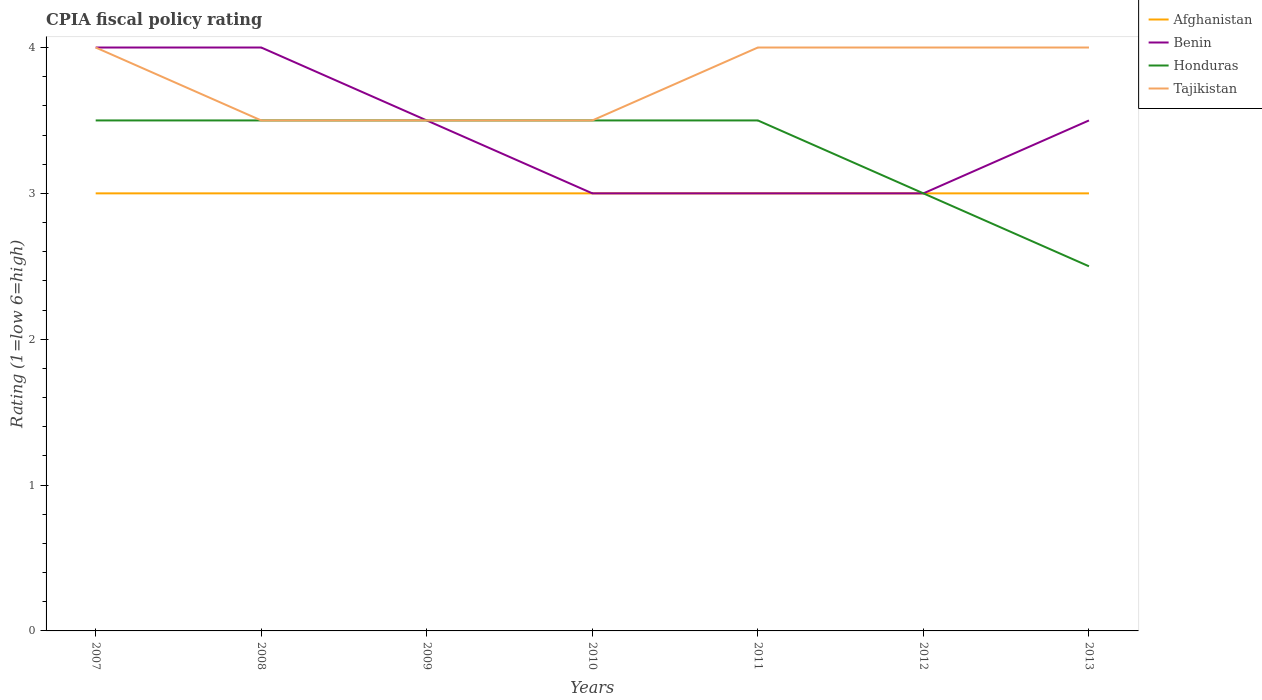How many different coloured lines are there?
Offer a very short reply. 4. Is the number of lines equal to the number of legend labels?
Keep it short and to the point. Yes. Across all years, what is the maximum CPIA rating in Honduras?
Provide a succinct answer. 2.5. In which year was the CPIA rating in Benin maximum?
Offer a terse response. 2010. What is the total CPIA rating in Benin in the graph?
Your answer should be compact. 0.5. What is the difference between the highest and the second highest CPIA rating in Benin?
Your response must be concise. 1. What is the difference between the highest and the lowest CPIA rating in Afghanistan?
Offer a very short reply. 0. Are the values on the major ticks of Y-axis written in scientific E-notation?
Make the answer very short. No. Does the graph contain any zero values?
Keep it short and to the point. No. Does the graph contain grids?
Your answer should be very brief. No. How are the legend labels stacked?
Your answer should be very brief. Vertical. What is the title of the graph?
Offer a terse response. CPIA fiscal policy rating. Does "Northern Mariana Islands" appear as one of the legend labels in the graph?
Make the answer very short. No. What is the Rating (1=low 6=high) in Benin in 2007?
Keep it short and to the point. 4. What is the Rating (1=low 6=high) of Honduras in 2008?
Keep it short and to the point. 3.5. What is the Rating (1=low 6=high) of Benin in 2009?
Your answer should be very brief. 3.5. What is the Rating (1=low 6=high) of Honduras in 2009?
Provide a short and direct response. 3.5. What is the Rating (1=low 6=high) in Benin in 2010?
Provide a succinct answer. 3. What is the Rating (1=low 6=high) in Honduras in 2010?
Keep it short and to the point. 3.5. What is the Rating (1=low 6=high) of Benin in 2011?
Provide a succinct answer. 3. What is the Rating (1=low 6=high) of Tajikistan in 2011?
Keep it short and to the point. 4. What is the Rating (1=low 6=high) of Afghanistan in 2012?
Make the answer very short. 3. What is the Rating (1=low 6=high) in Honduras in 2012?
Provide a succinct answer. 3. What is the Rating (1=low 6=high) of Tajikistan in 2012?
Offer a very short reply. 4. What is the Rating (1=low 6=high) of Afghanistan in 2013?
Ensure brevity in your answer.  3. Across all years, what is the maximum Rating (1=low 6=high) in Honduras?
Your response must be concise. 3.5. Across all years, what is the maximum Rating (1=low 6=high) in Tajikistan?
Keep it short and to the point. 4. Across all years, what is the minimum Rating (1=low 6=high) of Honduras?
Ensure brevity in your answer.  2.5. Across all years, what is the minimum Rating (1=low 6=high) of Tajikistan?
Ensure brevity in your answer.  3.5. What is the difference between the Rating (1=low 6=high) in Afghanistan in 2007 and that in 2008?
Keep it short and to the point. 0. What is the difference between the Rating (1=low 6=high) in Benin in 2007 and that in 2008?
Provide a succinct answer. 0. What is the difference between the Rating (1=low 6=high) of Honduras in 2007 and that in 2008?
Offer a very short reply. 0. What is the difference between the Rating (1=low 6=high) in Tajikistan in 2007 and that in 2008?
Provide a succinct answer. 0.5. What is the difference between the Rating (1=low 6=high) of Afghanistan in 2007 and that in 2009?
Offer a terse response. 0. What is the difference between the Rating (1=low 6=high) of Honduras in 2007 and that in 2009?
Give a very brief answer. 0. What is the difference between the Rating (1=low 6=high) in Tajikistan in 2007 and that in 2009?
Provide a succinct answer. 0.5. What is the difference between the Rating (1=low 6=high) in Honduras in 2007 and that in 2010?
Provide a short and direct response. 0. What is the difference between the Rating (1=low 6=high) in Benin in 2007 and that in 2011?
Provide a succinct answer. 1. What is the difference between the Rating (1=low 6=high) of Honduras in 2007 and that in 2011?
Keep it short and to the point. 0. What is the difference between the Rating (1=low 6=high) in Tajikistan in 2007 and that in 2011?
Your answer should be compact. 0. What is the difference between the Rating (1=low 6=high) of Afghanistan in 2007 and that in 2012?
Your answer should be very brief. 0. What is the difference between the Rating (1=low 6=high) in Benin in 2007 and that in 2012?
Your response must be concise. 1. What is the difference between the Rating (1=low 6=high) of Benin in 2007 and that in 2013?
Keep it short and to the point. 0.5. What is the difference between the Rating (1=low 6=high) in Afghanistan in 2008 and that in 2009?
Offer a very short reply. 0. What is the difference between the Rating (1=low 6=high) in Benin in 2008 and that in 2009?
Your answer should be compact. 0.5. What is the difference between the Rating (1=low 6=high) in Honduras in 2008 and that in 2010?
Keep it short and to the point. 0. What is the difference between the Rating (1=low 6=high) of Benin in 2008 and that in 2011?
Your answer should be very brief. 1. What is the difference between the Rating (1=low 6=high) of Honduras in 2008 and that in 2011?
Keep it short and to the point. 0. What is the difference between the Rating (1=low 6=high) of Afghanistan in 2008 and that in 2012?
Ensure brevity in your answer.  0. What is the difference between the Rating (1=low 6=high) of Honduras in 2008 and that in 2012?
Provide a short and direct response. 0.5. What is the difference between the Rating (1=low 6=high) in Tajikistan in 2008 and that in 2012?
Your response must be concise. -0.5. What is the difference between the Rating (1=low 6=high) in Afghanistan in 2008 and that in 2013?
Your answer should be compact. 0. What is the difference between the Rating (1=low 6=high) in Benin in 2009 and that in 2010?
Offer a terse response. 0.5. What is the difference between the Rating (1=low 6=high) of Honduras in 2009 and that in 2010?
Your answer should be very brief. 0. What is the difference between the Rating (1=low 6=high) of Afghanistan in 2009 and that in 2011?
Your answer should be very brief. 0. What is the difference between the Rating (1=low 6=high) in Tajikistan in 2009 and that in 2011?
Offer a very short reply. -0.5. What is the difference between the Rating (1=low 6=high) in Afghanistan in 2009 and that in 2012?
Ensure brevity in your answer.  0. What is the difference between the Rating (1=low 6=high) of Tajikistan in 2009 and that in 2012?
Offer a terse response. -0.5. What is the difference between the Rating (1=low 6=high) of Afghanistan in 2010 and that in 2011?
Make the answer very short. 0. What is the difference between the Rating (1=low 6=high) of Benin in 2010 and that in 2011?
Your answer should be compact. 0. What is the difference between the Rating (1=low 6=high) in Honduras in 2010 and that in 2011?
Make the answer very short. 0. What is the difference between the Rating (1=low 6=high) of Tajikistan in 2010 and that in 2011?
Give a very brief answer. -0.5. What is the difference between the Rating (1=low 6=high) of Afghanistan in 2010 and that in 2012?
Your response must be concise. 0. What is the difference between the Rating (1=low 6=high) in Benin in 2010 and that in 2012?
Your answer should be very brief. 0. What is the difference between the Rating (1=low 6=high) in Benin in 2010 and that in 2013?
Keep it short and to the point. -0.5. What is the difference between the Rating (1=low 6=high) of Tajikistan in 2010 and that in 2013?
Make the answer very short. -0.5. What is the difference between the Rating (1=low 6=high) of Afghanistan in 2011 and that in 2012?
Keep it short and to the point. 0. What is the difference between the Rating (1=low 6=high) in Benin in 2011 and that in 2012?
Your response must be concise. 0. What is the difference between the Rating (1=low 6=high) of Honduras in 2011 and that in 2012?
Your answer should be compact. 0.5. What is the difference between the Rating (1=low 6=high) of Tajikistan in 2011 and that in 2012?
Keep it short and to the point. 0. What is the difference between the Rating (1=low 6=high) of Honduras in 2011 and that in 2013?
Keep it short and to the point. 1. What is the difference between the Rating (1=low 6=high) of Honduras in 2012 and that in 2013?
Offer a terse response. 0.5. What is the difference between the Rating (1=low 6=high) of Tajikistan in 2012 and that in 2013?
Your response must be concise. 0. What is the difference between the Rating (1=low 6=high) of Afghanistan in 2007 and the Rating (1=low 6=high) of Benin in 2008?
Provide a short and direct response. -1. What is the difference between the Rating (1=low 6=high) of Afghanistan in 2007 and the Rating (1=low 6=high) of Honduras in 2008?
Offer a very short reply. -0.5. What is the difference between the Rating (1=low 6=high) of Benin in 2007 and the Rating (1=low 6=high) of Tajikistan in 2008?
Your answer should be very brief. 0.5. What is the difference between the Rating (1=low 6=high) of Honduras in 2007 and the Rating (1=low 6=high) of Tajikistan in 2008?
Make the answer very short. 0. What is the difference between the Rating (1=low 6=high) of Benin in 2007 and the Rating (1=low 6=high) of Honduras in 2009?
Ensure brevity in your answer.  0.5. What is the difference between the Rating (1=low 6=high) of Benin in 2007 and the Rating (1=low 6=high) of Tajikistan in 2009?
Make the answer very short. 0.5. What is the difference between the Rating (1=low 6=high) in Honduras in 2007 and the Rating (1=low 6=high) in Tajikistan in 2009?
Offer a very short reply. 0. What is the difference between the Rating (1=low 6=high) of Benin in 2007 and the Rating (1=low 6=high) of Honduras in 2010?
Your response must be concise. 0.5. What is the difference between the Rating (1=low 6=high) of Afghanistan in 2007 and the Rating (1=low 6=high) of Honduras in 2011?
Offer a very short reply. -0.5. What is the difference between the Rating (1=low 6=high) in Benin in 2007 and the Rating (1=low 6=high) in Tajikistan in 2011?
Keep it short and to the point. 0. What is the difference between the Rating (1=low 6=high) in Benin in 2007 and the Rating (1=low 6=high) in Tajikistan in 2012?
Your response must be concise. 0. What is the difference between the Rating (1=low 6=high) of Honduras in 2007 and the Rating (1=low 6=high) of Tajikistan in 2012?
Make the answer very short. -0.5. What is the difference between the Rating (1=low 6=high) of Afghanistan in 2007 and the Rating (1=low 6=high) of Honduras in 2013?
Make the answer very short. 0.5. What is the difference between the Rating (1=low 6=high) in Benin in 2007 and the Rating (1=low 6=high) in Tajikistan in 2013?
Keep it short and to the point. 0. What is the difference between the Rating (1=low 6=high) in Honduras in 2007 and the Rating (1=low 6=high) in Tajikistan in 2013?
Offer a terse response. -0.5. What is the difference between the Rating (1=low 6=high) of Afghanistan in 2008 and the Rating (1=low 6=high) of Benin in 2009?
Offer a very short reply. -0.5. What is the difference between the Rating (1=low 6=high) of Afghanistan in 2008 and the Rating (1=low 6=high) of Honduras in 2009?
Offer a terse response. -0.5. What is the difference between the Rating (1=low 6=high) in Benin in 2008 and the Rating (1=low 6=high) in Honduras in 2009?
Your answer should be compact. 0.5. What is the difference between the Rating (1=low 6=high) in Afghanistan in 2008 and the Rating (1=low 6=high) in Benin in 2010?
Your answer should be compact. 0. What is the difference between the Rating (1=low 6=high) of Afghanistan in 2008 and the Rating (1=low 6=high) of Honduras in 2010?
Your response must be concise. -0.5. What is the difference between the Rating (1=low 6=high) of Afghanistan in 2008 and the Rating (1=low 6=high) of Tajikistan in 2010?
Give a very brief answer. -0.5. What is the difference between the Rating (1=low 6=high) of Benin in 2008 and the Rating (1=low 6=high) of Tajikistan in 2010?
Your answer should be compact. 0.5. What is the difference between the Rating (1=low 6=high) in Afghanistan in 2008 and the Rating (1=low 6=high) in Benin in 2011?
Ensure brevity in your answer.  0. What is the difference between the Rating (1=low 6=high) of Honduras in 2008 and the Rating (1=low 6=high) of Tajikistan in 2011?
Make the answer very short. -0.5. What is the difference between the Rating (1=low 6=high) of Benin in 2008 and the Rating (1=low 6=high) of Tajikistan in 2012?
Ensure brevity in your answer.  0. What is the difference between the Rating (1=low 6=high) of Afghanistan in 2008 and the Rating (1=low 6=high) of Benin in 2013?
Your response must be concise. -0.5. What is the difference between the Rating (1=low 6=high) in Benin in 2008 and the Rating (1=low 6=high) in Tajikistan in 2013?
Ensure brevity in your answer.  0. What is the difference between the Rating (1=low 6=high) of Benin in 2009 and the Rating (1=low 6=high) of Honduras in 2010?
Keep it short and to the point. 0. What is the difference between the Rating (1=low 6=high) of Honduras in 2009 and the Rating (1=low 6=high) of Tajikistan in 2010?
Your answer should be compact. 0. What is the difference between the Rating (1=low 6=high) in Afghanistan in 2009 and the Rating (1=low 6=high) in Tajikistan in 2011?
Provide a short and direct response. -1. What is the difference between the Rating (1=low 6=high) of Benin in 2009 and the Rating (1=low 6=high) of Honduras in 2011?
Your answer should be very brief. 0. What is the difference between the Rating (1=low 6=high) in Afghanistan in 2009 and the Rating (1=low 6=high) in Benin in 2012?
Give a very brief answer. 0. What is the difference between the Rating (1=low 6=high) of Benin in 2009 and the Rating (1=low 6=high) of Honduras in 2012?
Your answer should be very brief. 0.5. What is the difference between the Rating (1=low 6=high) in Afghanistan in 2009 and the Rating (1=low 6=high) in Honduras in 2013?
Offer a very short reply. 0.5. What is the difference between the Rating (1=low 6=high) in Benin in 2009 and the Rating (1=low 6=high) in Honduras in 2013?
Offer a terse response. 1. What is the difference between the Rating (1=low 6=high) of Honduras in 2009 and the Rating (1=low 6=high) of Tajikistan in 2013?
Offer a terse response. -0.5. What is the difference between the Rating (1=low 6=high) in Afghanistan in 2010 and the Rating (1=low 6=high) in Benin in 2011?
Provide a short and direct response. 0. What is the difference between the Rating (1=low 6=high) of Benin in 2010 and the Rating (1=low 6=high) of Honduras in 2011?
Ensure brevity in your answer.  -0.5. What is the difference between the Rating (1=low 6=high) of Benin in 2010 and the Rating (1=low 6=high) of Tajikistan in 2011?
Provide a succinct answer. -1. What is the difference between the Rating (1=low 6=high) of Afghanistan in 2010 and the Rating (1=low 6=high) of Benin in 2012?
Your response must be concise. 0. What is the difference between the Rating (1=low 6=high) in Benin in 2010 and the Rating (1=low 6=high) in Tajikistan in 2012?
Offer a terse response. -1. What is the difference between the Rating (1=low 6=high) in Afghanistan in 2010 and the Rating (1=low 6=high) in Honduras in 2013?
Your answer should be very brief. 0.5. What is the difference between the Rating (1=low 6=high) of Afghanistan in 2010 and the Rating (1=low 6=high) of Tajikistan in 2013?
Make the answer very short. -1. What is the difference between the Rating (1=low 6=high) in Benin in 2010 and the Rating (1=low 6=high) in Tajikistan in 2013?
Your response must be concise. -1. What is the difference between the Rating (1=low 6=high) in Afghanistan in 2011 and the Rating (1=low 6=high) in Benin in 2012?
Your answer should be compact. 0. What is the difference between the Rating (1=low 6=high) in Afghanistan in 2011 and the Rating (1=low 6=high) in Tajikistan in 2012?
Make the answer very short. -1. What is the difference between the Rating (1=low 6=high) of Benin in 2011 and the Rating (1=low 6=high) of Honduras in 2012?
Your answer should be compact. 0. What is the difference between the Rating (1=low 6=high) in Afghanistan in 2011 and the Rating (1=low 6=high) in Benin in 2013?
Your response must be concise. -0.5. What is the difference between the Rating (1=low 6=high) in Afghanistan in 2011 and the Rating (1=low 6=high) in Honduras in 2013?
Offer a very short reply. 0.5. What is the difference between the Rating (1=low 6=high) in Afghanistan in 2012 and the Rating (1=low 6=high) in Benin in 2013?
Your answer should be compact. -0.5. What is the difference between the Rating (1=low 6=high) in Benin in 2012 and the Rating (1=low 6=high) in Honduras in 2013?
Provide a succinct answer. 0.5. What is the difference between the Rating (1=low 6=high) in Honduras in 2012 and the Rating (1=low 6=high) in Tajikistan in 2013?
Keep it short and to the point. -1. What is the average Rating (1=low 6=high) in Benin per year?
Your response must be concise. 3.43. What is the average Rating (1=low 6=high) of Honduras per year?
Give a very brief answer. 3.29. What is the average Rating (1=low 6=high) of Tajikistan per year?
Offer a terse response. 3.79. In the year 2007, what is the difference between the Rating (1=low 6=high) of Afghanistan and Rating (1=low 6=high) of Benin?
Keep it short and to the point. -1. In the year 2007, what is the difference between the Rating (1=low 6=high) of Afghanistan and Rating (1=low 6=high) of Honduras?
Make the answer very short. -0.5. In the year 2008, what is the difference between the Rating (1=low 6=high) in Afghanistan and Rating (1=low 6=high) in Tajikistan?
Your answer should be very brief. -0.5. In the year 2008, what is the difference between the Rating (1=low 6=high) in Honduras and Rating (1=low 6=high) in Tajikistan?
Offer a terse response. 0. In the year 2009, what is the difference between the Rating (1=low 6=high) of Afghanistan and Rating (1=low 6=high) of Honduras?
Your response must be concise. -0.5. In the year 2009, what is the difference between the Rating (1=low 6=high) of Benin and Rating (1=low 6=high) of Honduras?
Your response must be concise. 0. In the year 2009, what is the difference between the Rating (1=low 6=high) of Benin and Rating (1=low 6=high) of Tajikistan?
Make the answer very short. 0. In the year 2010, what is the difference between the Rating (1=low 6=high) of Afghanistan and Rating (1=low 6=high) of Tajikistan?
Your answer should be very brief. -0.5. In the year 2010, what is the difference between the Rating (1=low 6=high) of Benin and Rating (1=low 6=high) of Tajikistan?
Make the answer very short. -0.5. In the year 2010, what is the difference between the Rating (1=low 6=high) of Honduras and Rating (1=low 6=high) of Tajikistan?
Keep it short and to the point. 0. In the year 2011, what is the difference between the Rating (1=low 6=high) of Afghanistan and Rating (1=low 6=high) of Honduras?
Provide a short and direct response. -0.5. In the year 2011, what is the difference between the Rating (1=low 6=high) in Afghanistan and Rating (1=low 6=high) in Tajikistan?
Offer a very short reply. -1. In the year 2011, what is the difference between the Rating (1=low 6=high) of Benin and Rating (1=low 6=high) of Tajikistan?
Your answer should be compact. -1. In the year 2011, what is the difference between the Rating (1=low 6=high) in Honduras and Rating (1=low 6=high) in Tajikistan?
Give a very brief answer. -0.5. In the year 2012, what is the difference between the Rating (1=low 6=high) of Benin and Rating (1=low 6=high) of Honduras?
Offer a very short reply. 0. In the year 2013, what is the difference between the Rating (1=low 6=high) in Afghanistan and Rating (1=low 6=high) in Tajikistan?
Your answer should be compact. -1. In the year 2013, what is the difference between the Rating (1=low 6=high) in Benin and Rating (1=low 6=high) in Honduras?
Ensure brevity in your answer.  1. What is the ratio of the Rating (1=low 6=high) in Honduras in 2007 to that in 2008?
Your answer should be very brief. 1. What is the ratio of the Rating (1=low 6=high) in Honduras in 2007 to that in 2009?
Offer a terse response. 1. What is the ratio of the Rating (1=low 6=high) of Tajikistan in 2007 to that in 2009?
Offer a very short reply. 1.14. What is the ratio of the Rating (1=low 6=high) in Afghanistan in 2007 to that in 2010?
Offer a very short reply. 1. What is the ratio of the Rating (1=low 6=high) in Benin in 2007 to that in 2010?
Make the answer very short. 1.33. What is the ratio of the Rating (1=low 6=high) of Benin in 2007 to that in 2011?
Keep it short and to the point. 1.33. What is the ratio of the Rating (1=low 6=high) of Afghanistan in 2007 to that in 2012?
Provide a short and direct response. 1. What is the ratio of the Rating (1=low 6=high) in Benin in 2007 to that in 2012?
Make the answer very short. 1.33. What is the ratio of the Rating (1=low 6=high) in Benin in 2007 to that in 2013?
Keep it short and to the point. 1.14. What is the ratio of the Rating (1=low 6=high) in Honduras in 2007 to that in 2013?
Ensure brevity in your answer.  1.4. What is the ratio of the Rating (1=low 6=high) in Benin in 2008 to that in 2009?
Your answer should be compact. 1.14. What is the ratio of the Rating (1=low 6=high) of Tajikistan in 2008 to that in 2009?
Ensure brevity in your answer.  1. What is the ratio of the Rating (1=low 6=high) of Afghanistan in 2008 to that in 2010?
Offer a very short reply. 1. What is the ratio of the Rating (1=low 6=high) of Benin in 2008 to that in 2010?
Give a very brief answer. 1.33. What is the ratio of the Rating (1=low 6=high) in Afghanistan in 2008 to that in 2011?
Provide a succinct answer. 1. What is the ratio of the Rating (1=low 6=high) in Benin in 2008 to that in 2011?
Provide a short and direct response. 1.33. What is the ratio of the Rating (1=low 6=high) of Honduras in 2008 to that in 2011?
Provide a short and direct response. 1. What is the ratio of the Rating (1=low 6=high) in Tajikistan in 2008 to that in 2011?
Keep it short and to the point. 0.88. What is the ratio of the Rating (1=low 6=high) of Afghanistan in 2008 to that in 2012?
Keep it short and to the point. 1. What is the ratio of the Rating (1=low 6=high) of Tajikistan in 2008 to that in 2012?
Your answer should be very brief. 0.88. What is the ratio of the Rating (1=low 6=high) of Benin in 2008 to that in 2013?
Your answer should be very brief. 1.14. What is the ratio of the Rating (1=low 6=high) in Honduras in 2008 to that in 2013?
Your response must be concise. 1.4. What is the ratio of the Rating (1=low 6=high) of Afghanistan in 2009 to that in 2010?
Your answer should be compact. 1. What is the ratio of the Rating (1=low 6=high) in Benin in 2009 to that in 2010?
Offer a terse response. 1.17. What is the ratio of the Rating (1=low 6=high) in Honduras in 2009 to that in 2010?
Offer a terse response. 1. What is the ratio of the Rating (1=low 6=high) in Tajikistan in 2009 to that in 2011?
Provide a short and direct response. 0.88. What is the ratio of the Rating (1=low 6=high) in Afghanistan in 2009 to that in 2012?
Provide a short and direct response. 1. What is the ratio of the Rating (1=low 6=high) of Benin in 2009 to that in 2012?
Provide a succinct answer. 1.17. What is the ratio of the Rating (1=low 6=high) in Tajikistan in 2009 to that in 2012?
Provide a succinct answer. 0.88. What is the ratio of the Rating (1=low 6=high) of Afghanistan in 2009 to that in 2013?
Your answer should be very brief. 1. What is the ratio of the Rating (1=low 6=high) in Afghanistan in 2010 to that in 2013?
Ensure brevity in your answer.  1. What is the ratio of the Rating (1=low 6=high) in Benin in 2010 to that in 2013?
Offer a terse response. 0.86. What is the ratio of the Rating (1=low 6=high) of Honduras in 2010 to that in 2013?
Provide a short and direct response. 1.4. What is the ratio of the Rating (1=low 6=high) in Tajikistan in 2010 to that in 2013?
Make the answer very short. 0.88. What is the ratio of the Rating (1=low 6=high) in Afghanistan in 2011 to that in 2012?
Make the answer very short. 1. What is the ratio of the Rating (1=low 6=high) in Benin in 2011 to that in 2012?
Make the answer very short. 1. What is the ratio of the Rating (1=low 6=high) of Honduras in 2011 to that in 2012?
Your answer should be very brief. 1.17. What is the ratio of the Rating (1=low 6=high) of Tajikistan in 2011 to that in 2012?
Your response must be concise. 1. What is the ratio of the Rating (1=low 6=high) of Benin in 2011 to that in 2013?
Give a very brief answer. 0.86. What is the ratio of the Rating (1=low 6=high) of Afghanistan in 2012 to that in 2013?
Provide a short and direct response. 1. What is the difference between the highest and the second highest Rating (1=low 6=high) of Afghanistan?
Your answer should be compact. 0. What is the difference between the highest and the second highest Rating (1=low 6=high) of Benin?
Your answer should be very brief. 0. What is the difference between the highest and the second highest Rating (1=low 6=high) of Tajikistan?
Provide a succinct answer. 0. What is the difference between the highest and the lowest Rating (1=low 6=high) in Afghanistan?
Your response must be concise. 0. 